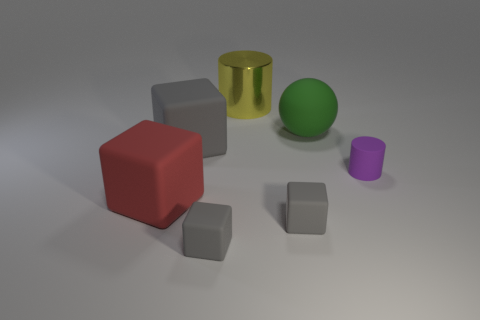Subtract all red cylinders. How many gray cubes are left? 3 Add 2 large spheres. How many objects exist? 9 Subtract all balls. How many objects are left? 6 Add 4 tiny gray objects. How many tiny gray objects exist? 6 Subtract 0 cyan blocks. How many objects are left? 7 Subtract all big green objects. Subtract all tiny gray metallic cylinders. How many objects are left? 6 Add 2 red rubber cubes. How many red rubber cubes are left? 3 